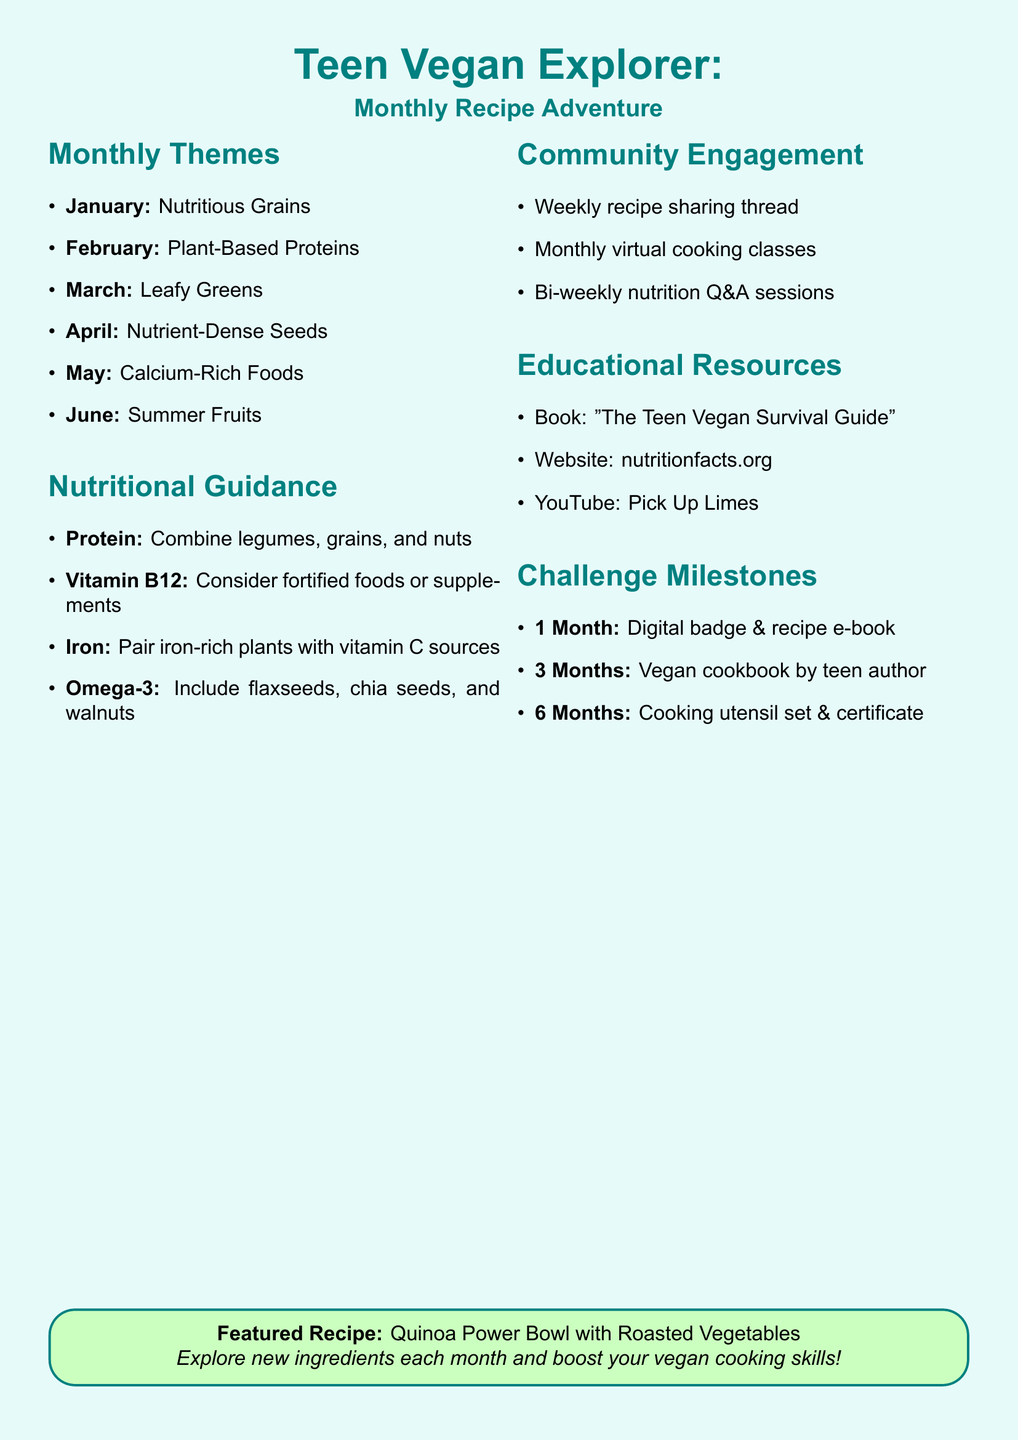What is the theme for January? The theme for January is "Nutritious Grains" as listed in the monthly themes section.
Answer: Nutritious Grains What is the featured recipe for February? The featured recipe for February is found under the Plant-Based Proteins theme.
Answer: Tempeh Tacos with Avocado Crema How many monthly themes are listed in the document? The document includes a list of monthly themes implying a count.
Answer: Six What are two examples of nutrient-dense seeds mentioned? The document lists Chia Seeds and Hemp Seeds under Nutrient-Dense Seeds.
Answer: Chia Seeds, Hemp Seeds What reward do you get after completing three months? The reward information for completing three months is directly stated in the challenge milestones section.
Answer: Vegan cookbook by a teen author What type of engagement activity happens every week? The document mentions community engagement activities and specifies one that happens weekly.
Answer: Recipe Sharing Platform What should be paired with iron-rich foods to enhance absorption? The nutritional guidance section advises pairing for better absorption.
Answer: Vitamin C sources Who is the author of "The Teen Vegan Survival Guide"? The document lists educational resources where the author of the specified book is mentioned.
Answer: Zoe Rosenberg 